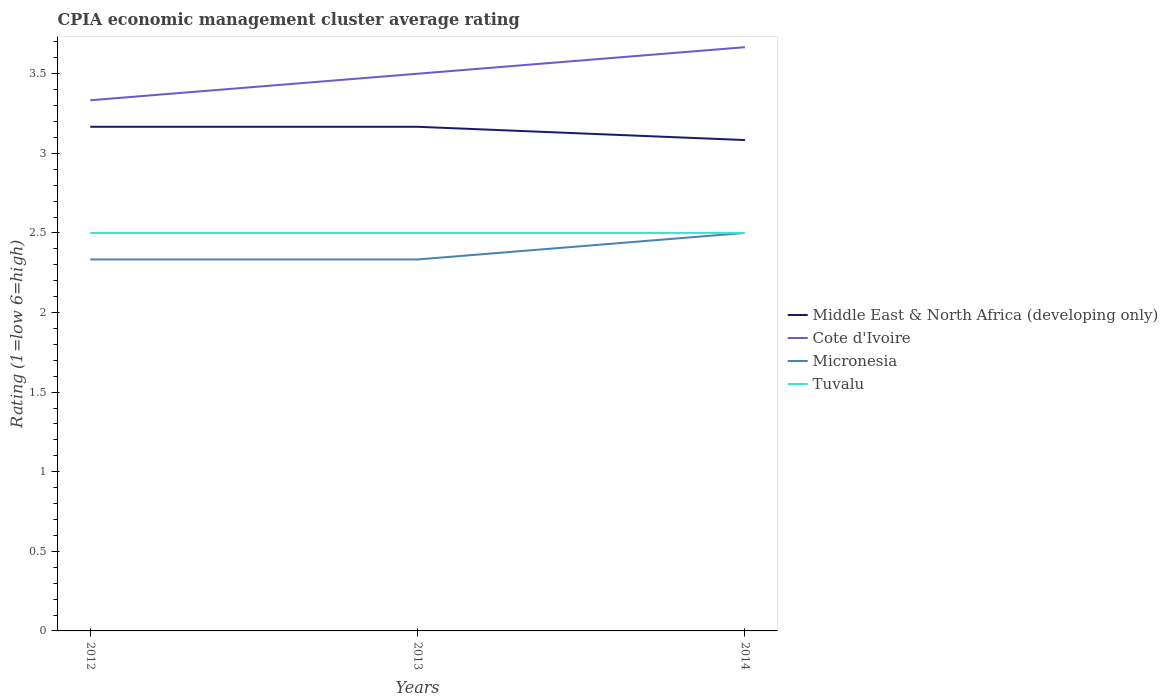How many different coloured lines are there?
Your response must be concise. 4. Is the number of lines equal to the number of legend labels?
Provide a succinct answer. Yes. Across all years, what is the maximum CPIA rating in Micronesia?
Ensure brevity in your answer.  2.33. In which year was the CPIA rating in Cote d'Ivoire maximum?
Your response must be concise. 2012. What is the difference between the highest and the second highest CPIA rating in Micronesia?
Ensure brevity in your answer.  0.17. What is the difference between the highest and the lowest CPIA rating in Tuvalu?
Give a very brief answer. 0. Are the values on the major ticks of Y-axis written in scientific E-notation?
Your answer should be very brief. No. Does the graph contain grids?
Keep it short and to the point. No. How are the legend labels stacked?
Offer a terse response. Vertical. What is the title of the graph?
Your response must be concise. CPIA economic management cluster average rating. Does "Bhutan" appear as one of the legend labels in the graph?
Your response must be concise. No. What is the label or title of the X-axis?
Provide a short and direct response. Years. What is the label or title of the Y-axis?
Your answer should be compact. Rating (1=low 6=high). What is the Rating (1=low 6=high) of Middle East & North Africa (developing only) in 2012?
Ensure brevity in your answer.  3.17. What is the Rating (1=low 6=high) in Cote d'Ivoire in 2012?
Offer a terse response. 3.33. What is the Rating (1=low 6=high) of Micronesia in 2012?
Your answer should be compact. 2.33. What is the Rating (1=low 6=high) in Middle East & North Africa (developing only) in 2013?
Offer a terse response. 3.17. What is the Rating (1=low 6=high) in Cote d'Ivoire in 2013?
Keep it short and to the point. 3.5. What is the Rating (1=low 6=high) of Micronesia in 2013?
Your answer should be very brief. 2.33. What is the Rating (1=low 6=high) in Tuvalu in 2013?
Offer a very short reply. 2.5. What is the Rating (1=low 6=high) of Middle East & North Africa (developing only) in 2014?
Offer a terse response. 3.08. What is the Rating (1=low 6=high) in Cote d'Ivoire in 2014?
Keep it short and to the point. 3.67. Across all years, what is the maximum Rating (1=low 6=high) of Middle East & North Africa (developing only)?
Your response must be concise. 3.17. Across all years, what is the maximum Rating (1=low 6=high) of Cote d'Ivoire?
Provide a succinct answer. 3.67. Across all years, what is the maximum Rating (1=low 6=high) in Tuvalu?
Your response must be concise. 2.5. Across all years, what is the minimum Rating (1=low 6=high) in Middle East & North Africa (developing only)?
Your response must be concise. 3.08. Across all years, what is the minimum Rating (1=low 6=high) of Cote d'Ivoire?
Your answer should be very brief. 3.33. Across all years, what is the minimum Rating (1=low 6=high) in Micronesia?
Your answer should be compact. 2.33. What is the total Rating (1=low 6=high) in Middle East & North Africa (developing only) in the graph?
Ensure brevity in your answer.  9.42. What is the total Rating (1=low 6=high) of Cote d'Ivoire in the graph?
Give a very brief answer. 10.5. What is the total Rating (1=low 6=high) of Micronesia in the graph?
Your answer should be compact. 7.17. What is the total Rating (1=low 6=high) in Tuvalu in the graph?
Your answer should be compact. 7.5. What is the difference between the Rating (1=low 6=high) of Micronesia in 2012 and that in 2013?
Give a very brief answer. 0. What is the difference between the Rating (1=low 6=high) in Tuvalu in 2012 and that in 2013?
Keep it short and to the point. 0. What is the difference between the Rating (1=low 6=high) in Middle East & North Africa (developing only) in 2012 and that in 2014?
Give a very brief answer. 0.08. What is the difference between the Rating (1=low 6=high) in Cote d'Ivoire in 2012 and that in 2014?
Make the answer very short. -0.33. What is the difference between the Rating (1=low 6=high) in Micronesia in 2012 and that in 2014?
Make the answer very short. -0.17. What is the difference between the Rating (1=low 6=high) in Middle East & North Africa (developing only) in 2013 and that in 2014?
Give a very brief answer. 0.08. What is the difference between the Rating (1=low 6=high) of Tuvalu in 2013 and that in 2014?
Your answer should be compact. 0. What is the difference between the Rating (1=low 6=high) of Middle East & North Africa (developing only) in 2012 and the Rating (1=low 6=high) of Cote d'Ivoire in 2013?
Your answer should be very brief. -0.33. What is the difference between the Rating (1=low 6=high) of Cote d'Ivoire in 2012 and the Rating (1=low 6=high) of Micronesia in 2013?
Your answer should be compact. 1. What is the difference between the Rating (1=low 6=high) in Micronesia in 2012 and the Rating (1=low 6=high) in Tuvalu in 2013?
Keep it short and to the point. -0.17. What is the difference between the Rating (1=low 6=high) in Middle East & North Africa (developing only) in 2012 and the Rating (1=low 6=high) in Cote d'Ivoire in 2014?
Offer a terse response. -0.5. What is the difference between the Rating (1=low 6=high) in Middle East & North Africa (developing only) in 2012 and the Rating (1=low 6=high) in Micronesia in 2014?
Ensure brevity in your answer.  0.67. What is the difference between the Rating (1=low 6=high) in Middle East & North Africa (developing only) in 2012 and the Rating (1=low 6=high) in Tuvalu in 2014?
Provide a short and direct response. 0.67. What is the difference between the Rating (1=low 6=high) of Cote d'Ivoire in 2012 and the Rating (1=low 6=high) of Tuvalu in 2014?
Provide a short and direct response. 0.83. What is the difference between the Rating (1=low 6=high) of Micronesia in 2012 and the Rating (1=low 6=high) of Tuvalu in 2014?
Make the answer very short. -0.17. What is the difference between the Rating (1=low 6=high) of Middle East & North Africa (developing only) in 2013 and the Rating (1=low 6=high) of Tuvalu in 2014?
Ensure brevity in your answer.  0.67. What is the difference between the Rating (1=low 6=high) of Micronesia in 2013 and the Rating (1=low 6=high) of Tuvalu in 2014?
Your answer should be compact. -0.17. What is the average Rating (1=low 6=high) of Middle East & North Africa (developing only) per year?
Your response must be concise. 3.14. What is the average Rating (1=low 6=high) of Cote d'Ivoire per year?
Provide a succinct answer. 3.5. What is the average Rating (1=low 6=high) of Micronesia per year?
Give a very brief answer. 2.39. What is the average Rating (1=low 6=high) of Tuvalu per year?
Ensure brevity in your answer.  2.5. In the year 2012, what is the difference between the Rating (1=low 6=high) in Middle East & North Africa (developing only) and Rating (1=low 6=high) in Cote d'Ivoire?
Offer a terse response. -0.17. In the year 2012, what is the difference between the Rating (1=low 6=high) in Middle East & North Africa (developing only) and Rating (1=low 6=high) in Micronesia?
Your answer should be very brief. 0.83. In the year 2012, what is the difference between the Rating (1=low 6=high) of Micronesia and Rating (1=low 6=high) of Tuvalu?
Give a very brief answer. -0.17. In the year 2013, what is the difference between the Rating (1=low 6=high) in Middle East & North Africa (developing only) and Rating (1=low 6=high) in Micronesia?
Your answer should be compact. 0.83. In the year 2013, what is the difference between the Rating (1=low 6=high) of Middle East & North Africa (developing only) and Rating (1=low 6=high) of Tuvalu?
Provide a succinct answer. 0.67. In the year 2013, what is the difference between the Rating (1=low 6=high) in Cote d'Ivoire and Rating (1=low 6=high) in Tuvalu?
Make the answer very short. 1. In the year 2014, what is the difference between the Rating (1=low 6=high) in Middle East & North Africa (developing only) and Rating (1=low 6=high) in Cote d'Ivoire?
Offer a very short reply. -0.58. In the year 2014, what is the difference between the Rating (1=low 6=high) of Middle East & North Africa (developing only) and Rating (1=low 6=high) of Micronesia?
Offer a terse response. 0.58. In the year 2014, what is the difference between the Rating (1=low 6=high) in Middle East & North Africa (developing only) and Rating (1=low 6=high) in Tuvalu?
Ensure brevity in your answer.  0.58. What is the ratio of the Rating (1=low 6=high) in Middle East & North Africa (developing only) in 2012 to that in 2013?
Keep it short and to the point. 1. What is the ratio of the Rating (1=low 6=high) of Tuvalu in 2012 to that in 2014?
Keep it short and to the point. 1. What is the ratio of the Rating (1=low 6=high) of Middle East & North Africa (developing only) in 2013 to that in 2014?
Your answer should be very brief. 1.03. What is the ratio of the Rating (1=low 6=high) of Cote d'Ivoire in 2013 to that in 2014?
Make the answer very short. 0.95. What is the ratio of the Rating (1=low 6=high) of Micronesia in 2013 to that in 2014?
Your answer should be compact. 0.93. What is the ratio of the Rating (1=low 6=high) of Tuvalu in 2013 to that in 2014?
Give a very brief answer. 1. What is the difference between the highest and the second highest Rating (1=low 6=high) of Middle East & North Africa (developing only)?
Provide a short and direct response. 0. What is the difference between the highest and the lowest Rating (1=low 6=high) of Middle East & North Africa (developing only)?
Provide a succinct answer. 0.08. What is the difference between the highest and the lowest Rating (1=low 6=high) of Micronesia?
Offer a terse response. 0.17. 